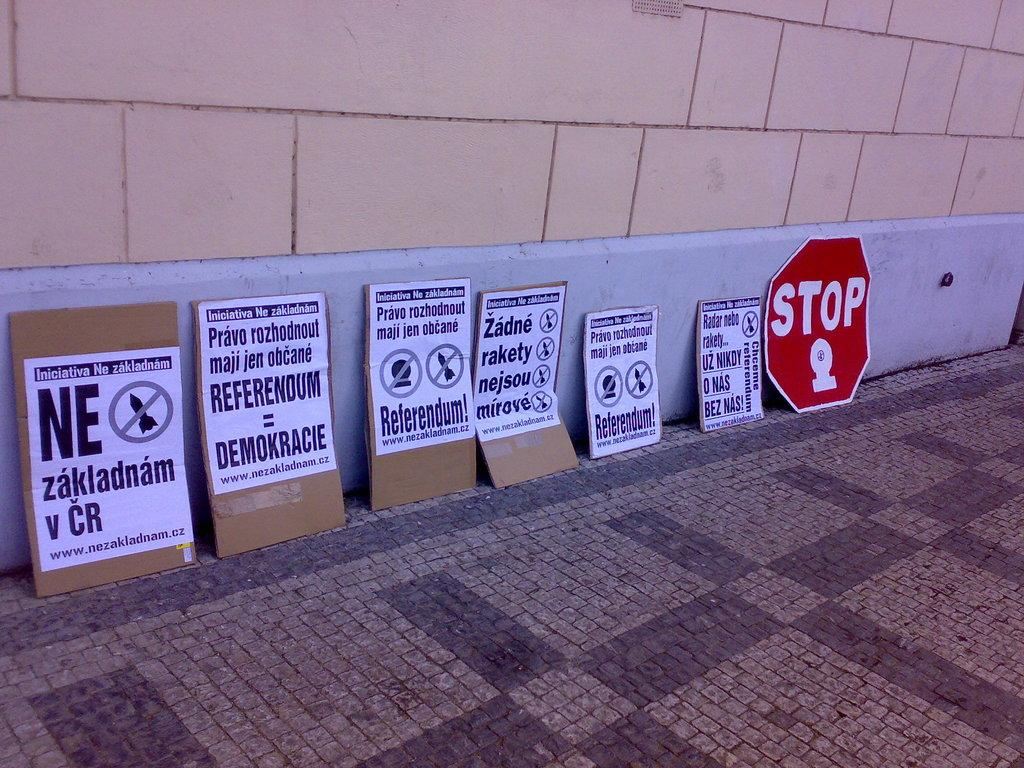<image>
Describe the image concisely. a stop sign that is against a gray wall 